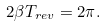Convert formula to latex. <formula><loc_0><loc_0><loc_500><loc_500>2 \beta T _ { r e v } = 2 \pi .</formula> 